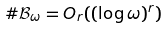Convert formula to latex. <formula><loc_0><loc_0><loc_500><loc_500>\# \mathcal { B } _ { \omega } = O _ { r } ( ( \log \omega ) ^ { r } )</formula> 